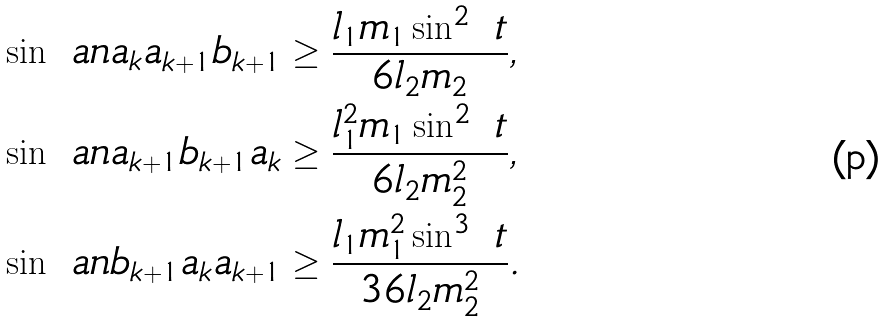Convert formula to latex. <formula><loc_0><loc_0><loc_500><loc_500>\sin \ a n { a _ { k } a _ { k + 1 } b _ { k + 1 } } & \geq \frac { l _ { 1 } m _ { 1 } \sin ^ { 2 } \ t } { 6 l _ { 2 } m _ { 2 } } , \\ \sin \ a n { a _ { k + 1 } b _ { k + 1 } a _ { k } } & \geq \frac { l _ { 1 } ^ { 2 } m _ { 1 } \sin ^ { 2 } \ t } { 6 l _ { 2 } m _ { 2 } ^ { 2 } } , \\ \sin \ a n { b _ { k + 1 } a _ { k } a _ { k + 1 } } & \geq \frac { l _ { 1 } m _ { 1 } ^ { 2 } \sin ^ { 3 } \ t } { 3 6 l _ { 2 } m _ { 2 } ^ { 2 } } .</formula> 